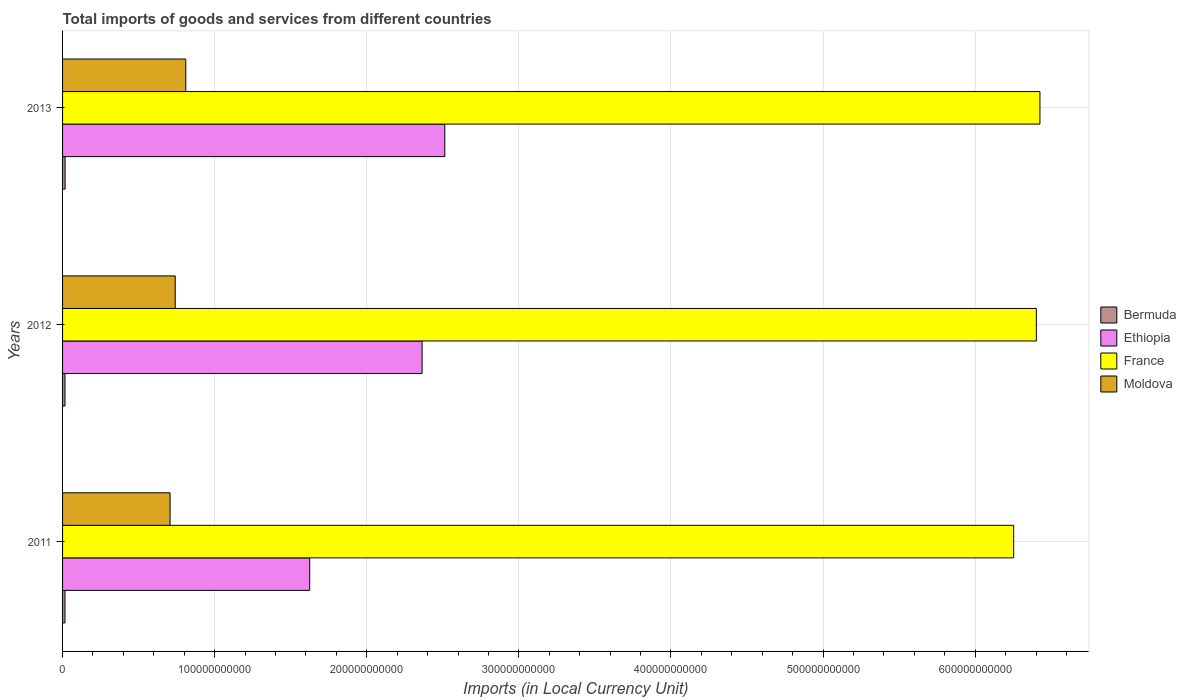How many different coloured bars are there?
Your answer should be very brief. 4. Are the number of bars on each tick of the Y-axis equal?
Your answer should be compact. Yes. How many bars are there on the 3rd tick from the top?
Your answer should be compact. 4. What is the label of the 1st group of bars from the top?
Provide a succinct answer. 2013. In how many cases, is the number of bars for a given year not equal to the number of legend labels?
Your response must be concise. 0. What is the Amount of goods and services imports in Bermuda in 2013?
Offer a terse response. 1.65e+09. Across all years, what is the maximum Amount of goods and services imports in France?
Make the answer very short. 6.43e+11. Across all years, what is the minimum Amount of goods and services imports in France?
Give a very brief answer. 6.25e+11. In which year was the Amount of goods and services imports in France maximum?
Give a very brief answer. 2013. What is the total Amount of goods and services imports in Bermuda in the graph?
Your answer should be compact. 4.84e+09. What is the difference between the Amount of goods and services imports in Bermuda in 2012 and that in 2013?
Make the answer very short. -6.26e+07. What is the difference between the Amount of goods and services imports in Ethiopia in 2011 and the Amount of goods and services imports in Moldova in 2013?
Ensure brevity in your answer.  8.15e+1. What is the average Amount of goods and services imports in France per year?
Your response must be concise. 6.36e+11. In the year 2012, what is the difference between the Amount of goods and services imports in Moldova and Amount of goods and services imports in Bermuda?
Your response must be concise. 7.25e+1. What is the ratio of the Amount of goods and services imports in Ethiopia in 2011 to that in 2012?
Provide a succinct answer. 0.69. Is the Amount of goods and services imports in Bermuda in 2011 less than that in 2013?
Offer a terse response. Yes. What is the difference between the highest and the second highest Amount of goods and services imports in France?
Your answer should be very brief. 2.34e+09. What is the difference between the highest and the lowest Amount of goods and services imports in Bermuda?
Give a very brief answer. 6.26e+07. In how many years, is the Amount of goods and services imports in Bermuda greater than the average Amount of goods and services imports in Bermuda taken over all years?
Provide a short and direct response. 1. Is the sum of the Amount of goods and services imports in Bermuda in 2011 and 2013 greater than the maximum Amount of goods and services imports in Moldova across all years?
Provide a short and direct response. No. Is it the case that in every year, the sum of the Amount of goods and services imports in France and Amount of goods and services imports in Moldova is greater than the sum of Amount of goods and services imports in Ethiopia and Amount of goods and services imports in Bermuda?
Provide a short and direct response. Yes. What does the 3rd bar from the top in 2012 represents?
Ensure brevity in your answer.  Ethiopia. How many bars are there?
Provide a succinct answer. 12. How many years are there in the graph?
Offer a very short reply. 3. What is the difference between two consecutive major ticks on the X-axis?
Offer a very short reply. 1.00e+11. Does the graph contain grids?
Your answer should be very brief. Yes. What is the title of the graph?
Make the answer very short. Total imports of goods and services from different countries. What is the label or title of the X-axis?
Keep it short and to the point. Imports (in Local Currency Unit). What is the label or title of the Y-axis?
Provide a succinct answer. Years. What is the Imports (in Local Currency Unit) of Bermuda in 2011?
Provide a succinct answer. 1.60e+09. What is the Imports (in Local Currency Unit) in Ethiopia in 2011?
Offer a very short reply. 1.62e+11. What is the Imports (in Local Currency Unit) in France in 2011?
Your answer should be compact. 6.25e+11. What is the Imports (in Local Currency Unit) in Moldova in 2011?
Ensure brevity in your answer.  7.07e+1. What is the Imports (in Local Currency Unit) in Bermuda in 2012?
Offer a very short reply. 1.59e+09. What is the Imports (in Local Currency Unit) in Ethiopia in 2012?
Keep it short and to the point. 2.36e+11. What is the Imports (in Local Currency Unit) in France in 2012?
Your response must be concise. 6.40e+11. What is the Imports (in Local Currency Unit) in Moldova in 2012?
Offer a terse response. 7.41e+1. What is the Imports (in Local Currency Unit) in Bermuda in 2013?
Your answer should be very brief. 1.65e+09. What is the Imports (in Local Currency Unit) of Ethiopia in 2013?
Give a very brief answer. 2.51e+11. What is the Imports (in Local Currency Unit) of France in 2013?
Offer a terse response. 6.43e+11. What is the Imports (in Local Currency Unit) of Moldova in 2013?
Ensure brevity in your answer.  8.10e+1. Across all years, what is the maximum Imports (in Local Currency Unit) in Bermuda?
Make the answer very short. 1.65e+09. Across all years, what is the maximum Imports (in Local Currency Unit) in Ethiopia?
Make the answer very short. 2.51e+11. Across all years, what is the maximum Imports (in Local Currency Unit) in France?
Your response must be concise. 6.43e+11. Across all years, what is the maximum Imports (in Local Currency Unit) in Moldova?
Ensure brevity in your answer.  8.10e+1. Across all years, what is the minimum Imports (in Local Currency Unit) in Bermuda?
Provide a succinct answer. 1.59e+09. Across all years, what is the minimum Imports (in Local Currency Unit) of Ethiopia?
Your answer should be compact. 1.62e+11. Across all years, what is the minimum Imports (in Local Currency Unit) of France?
Your answer should be compact. 6.25e+11. Across all years, what is the minimum Imports (in Local Currency Unit) in Moldova?
Your response must be concise. 7.07e+1. What is the total Imports (in Local Currency Unit) of Bermuda in the graph?
Offer a very short reply. 4.84e+09. What is the total Imports (in Local Currency Unit) in Ethiopia in the graph?
Give a very brief answer. 6.50e+11. What is the total Imports (in Local Currency Unit) in France in the graph?
Ensure brevity in your answer.  1.91e+12. What is the total Imports (in Local Currency Unit) of Moldova in the graph?
Your response must be concise. 2.26e+11. What is the difference between the Imports (in Local Currency Unit) of Bermuda in 2011 and that in 2012?
Provide a succinct answer. 1.42e+07. What is the difference between the Imports (in Local Currency Unit) in Ethiopia in 2011 and that in 2012?
Your response must be concise. -7.39e+1. What is the difference between the Imports (in Local Currency Unit) in France in 2011 and that in 2012?
Make the answer very short. -1.49e+1. What is the difference between the Imports (in Local Currency Unit) of Moldova in 2011 and that in 2012?
Your answer should be compact. -3.38e+09. What is the difference between the Imports (in Local Currency Unit) of Bermuda in 2011 and that in 2013?
Provide a succinct answer. -4.84e+07. What is the difference between the Imports (in Local Currency Unit) in Ethiopia in 2011 and that in 2013?
Give a very brief answer. -8.88e+1. What is the difference between the Imports (in Local Currency Unit) in France in 2011 and that in 2013?
Offer a very short reply. -1.73e+1. What is the difference between the Imports (in Local Currency Unit) in Moldova in 2011 and that in 2013?
Provide a short and direct response. -1.03e+1. What is the difference between the Imports (in Local Currency Unit) in Bermuda in 2012 and that in 2013?
Provide a short and direct response. -6.26e+07. What is the difference between the Imports (in Local Currency Unit) of Ethiopia in 2012 and that in 2013?
Offer a terse response. -1.49e+1. What is the difference between the Imports (in Local Currency Unit) in France in 2012 and that in 2013?
Your answer should be very brief. -2.34e+09. What is the difference between the Imports (in Local Currency Unit) in Moldova in 2012 and that in 2013?
Ensure brevity in your answer.  -6.95e+09. What is the difference between the Imports (in Local Currency Unit) of Bermuda in 2011 and the Imports (in Local Currency Unit) of Ethiopia in 2012?
Make the answer very short. -2.35e+11. What is the difference between the Imports (in Local Currency Unit) of Bermuda in 2011 and the Imports (in Local Currency Unit) of France in 2012?
Offer a very short reply. -6.39e+11. What is the difference between the Imports (in Local Currency Unit) of Bermuda in 2011 and the Imports (in Local Currency Unit) of Moldova in 2012?
Your answer should be compact. -7.25e+1. What is the difference between the Imports (in Local Currency Unit) in Ethiopia in 2011 and the Imports (in Local Currency Unit) in France in 2012?
Provide a succinct answer. -4.78e+11. What is the difference between the Imports (in Local Currency Unit) of Ethiopia in 2011 and the Imports (in Local Currency Unit) of Moldova in 2012?
Give a very brief answer. 8.84e+1. What is the difference between the Imports (in Local Currency Unit) of France in 2011 and the Imports (in Local Currency Unit) of Moldova in 2012?
Keep it short and to the point. 5.51e+11. What is the difference between the Imports (in Local Currency Unit) in Bermuda in 2011 and the Imports (in Local Currency Unit) in Ethiopia in 2013?
Make the answer very short. -2.50e+11. What is the difference between the Imports (in Local Currency Unit) of Bermuda in 2011 and the Imports (in Local Currency Unit) of France in 2013?
Make the answer very short. -6.41e+11. What is the difference between the Imports (in Local Currency Unit) of Bermuda in 2011 and the Imports (in Local Currency Unit) of Moldova in 2013?
Keep it short and to the point. -7.94e+1. What is the difference between the Imports (in Local Currency Unit) of Ethiopia in 2011 and the Imports (in Local Currency Unit) of France in 2013?
Make the answer very short. -4.80e+11. What is the difference between the Imports (in Local Currency Unit) in Ethiopia in 2011 and the Imports (in Local Currency Unit) in Moldova in 2013?
Give a very brief answer. 8.15e+1. What is the difference between the Imports (in Local Currency Unit) of France in 2011 and the Imports (in Local Currency Unit) of Moldova in 2013?
Ensure brevity in your answer.  5.44e+11. What is the difference between the Imports (in Local Currency Unit) in Bermuda in 2012 and the Imports (in Local Currency Unit) in Ethiopia in 2013?
Give a very brief answer. -2.50e+11. What is the difference between the Imports (in Local Currency Unit) in Bermuda in 2012 and the Imports (in Local Currency Unit) in France in 2013?
Your answer should be very brief. -6.41e+11. What is the difference between the Imports (in Local Currency Unit) in Bermuda in 2012 and the Imports (in Local Currency Unit) in Moldova in 2013?
Provide a succinct answer. -7.94e+1. What is the difference between the Imports (in Local Currency Unit) of Ethiopia in 2012 and the Imports (in Local Currency Unit) of France in 2013?
Your answer should be compact. -4.06e+11. What is the difference between the Imports (in Local Currency Unit) in Ethiopia in 2012 and the Imports (in Local Currency Unit) in Moldova in 2013?
Your response must be concise. 1.55e+11. What is the difference between the Imports (in Local Currency Unit) of France in 2012 and the Imports (in Local Currency Unit) of Moldova in 2013?
Give a very brief answer. 5.59e+11. What is the average Imports (in Local Currency Unit) of Bermuda per year?
Give a very brief answer. 1.61e+09. What is the average Imports (in Local Currency Unit) of Ethiopia per year?
Your answer should be compact. 2.17e+11. What is the average Imports (in Local Currency Unit) of France per year?
Provide a succinct answer. 6.36e+11. What is the average Imports (in Local Currency Unit) in Moldova per year?
Your answer should be very brief. 7.52e+1. In the year 2011, what is the difference between the Imports (in Local Currency Unit) of Bermuda and Imports (in Local Currency Unit) of Ethiopia?
Provide a succinct answer. -1.61e+11. In the year 2011, what is the difference between the Imports (in Local Currency Unit) in Bermuda and Imports (in Local Currency Unit) in France?
Give a very brief answer. -6.24e+11. In the year 2011, what is the difference between the Imports (in Local Currency Unit) in Bermuda and Imports (in Local Currency Unit) in Moldova?
Your answer should be very brief. -6.91e+1. In the year 2011, what is the difference between the Imports (in Local Currency Unit) of Ethiopia and Imports (in Local Currency Unit) of France?
Offer a terse response. -4.63e+11. In the year 2011, what is the difference between the Imports (in Local Currency Unit) in Ethiopia and Imports (in Local Currency Unit) in Moldova?
Your response must be concise. 9.18e+1. In the year 2011, what is the difference between the Imports (in Local Currency Unit) of France and Imports (in Local Currency Unit) of Moldova?
Provide a short and direct response. 5.55e+11. In the year 2012, what is the difference between the Imports (in Local Currency Unit) of Bermuda and Imports (in Local Currency Unit) of Ethiopia?
Provide a succinct answer. -2.35e+11. In the year 2012, what is the difference between the Imports (in Local Currency Unit) in Bermuda and Imports (in Local Currency Unit) in France?
Make the answer very short. -6.39e+11. In the year 2012, what is the difference between the Imports (in Local Currency Unit) in Bermuda and Imports (in Local Currency Unit) in Moldova?
Provide a succinct answer. -7.25e+1. In the year 2012, what is the difference between the Imports (in Local Currency Unit) of Ethiopia and Imports (in Local Currency Unit) of France?
Your answer should be very brief. -4.04e+11. In the year 2012, what is the difference between the Imports (in Local Currency Unit) of Ethiopia and Imports (in Local Currency Unit) of Moldova?
Give a very brief answer. 1.62e+11. In the year 2012, what is the difference between the Imports (in Local Currency Unit) of France and Imports (in Local Currency Unit) of Moldova?
Your answer should be very brief. 5.66e+11. In the year 2013, what is the difference between the Imports (in Local Currency Unit) in Bermuda and Imports (in Local Currency Unit) in Ethiopia?
Give a very brief answer. -2.50e+11. In the year 2013, what is the difference between the Imports (in Local Currency Unit) in Bermuda and Imports (in Local Currency Unit) in France?
Provide a succinct answer. -6.41e+11. In the year 2013, what is the difference between the Imports (in Local Currency Unit) of Bermuda and Imports (in Local Currency Unit) of Moldova?
Offer a terse response. -7.94e+1. In the year 2013, what is the difference between the Imports (in Local Currency Unit) in Ethiopia and Imports (in Local Currency Unit) in France?
Provide a short and direct response. -3.91e+11. In the year 2013, what is the difference between the Imports (in Local Currency Unit) of Ethiopia and Imports (in Local Currency Unit) of Moldova?
Provide a short and direct response. 1.70e+11. In the year 2013, what is the difference between the Imports (in Local Currency Unit) of France and Imports (in Local Currency Unit) of Moldova?
Your answer should be compact. 5.62e+11. What is the ratio of the Imports (in Local Currency Unit) in Bermuda in 2011 to that in 2012?
Make the answer very short. 1.01. What is the ratio of the Imports (in Local Currency Unit) of Ethiopia in 2011 to that in 2012?
Keep it short and to the point. 0.69. What is the ratio of the Imports (in Local Currency Unit) of France in 2011 to that in 2012?
Make the answer very short. 0.98. What is the ratio of the Imports (in Local Currency Unit) in Moldova in 2011 to that in 2012?
Ensure brevity in your answer.  0.95. What is the ratio of the Imports (in Local Currency Unit) of Bermuda in 2011 to that in 2013?
Your answer should be compact. 0.97. What is the ratio of the Imports (in Local Currency Unit) of Ethiopia in 2011 to that in 2013?
Give a very brief answer. 0.65. What is the ratio of the Imports (in Local Currency Unit) of France in 2011 to that in 2013?
Provide a short and direct response. 0.97. What is the ratio of the Imports (in Local Currency Unit) in Moldova in 2011 to that in 2013?
Provide a short and direct response. 0.87. What is the ratio of the Imports (in Local Currency Unit) of Bermuda in 2012 to that in 2013?
Your answer should be very brief. 0.96. What is the ratio of the Imports (in Local Currency Unit) of Ethiopia in 2012 to that in 2013?
Your answer should be compact. 0.94. What is the ratio of the Imports (in Local Currency Unit) of France in 2012 to that in 2013?
Your response must be concise. 1. What is the ratio of the Imports (in Local Currency Unit) in Moldova in 2012 to that in 2013?
Ensure brevity in your answer.  0.91. What is the difference between the highest and the second highest Imports (in Local Currency Unit) of Bermuda?
Ensure brevity in your answer.  4.84e+07. What is the difference between the highest and the second highest Imports (in Local Currency Unit) of Ethiopia?
Provide a succinct answer. 1.49e+1. What is the difference between the highest and the second highest Imports (in Local Currency Unit) of France?
Your answer should be compact. 2.34e+09. What is the difference between the highest and the second highest Imports (in Local Currency Unit) of Moldova?
Offer a terse response. 6.95e+09. What is the difference between the highest and the lowest Imports (in Local Currency Unit) of Bermuda?
Ensure brevity in your answer.  6.26e+07. What is the difference between the highest and the lowest Imports (in Local Currency Unit) in Ethiopia?
Offer a terse response. 8.88e+1. What is the difference between the highest and the lowest Imports (in Local Currency Unit) in France?
Your response must be concise. 1.73e+1. What is the difference between the highest and the lowest Imports (in Local Currency Unit) of Moldova?
Your response must be concise. 1.03e+1. 